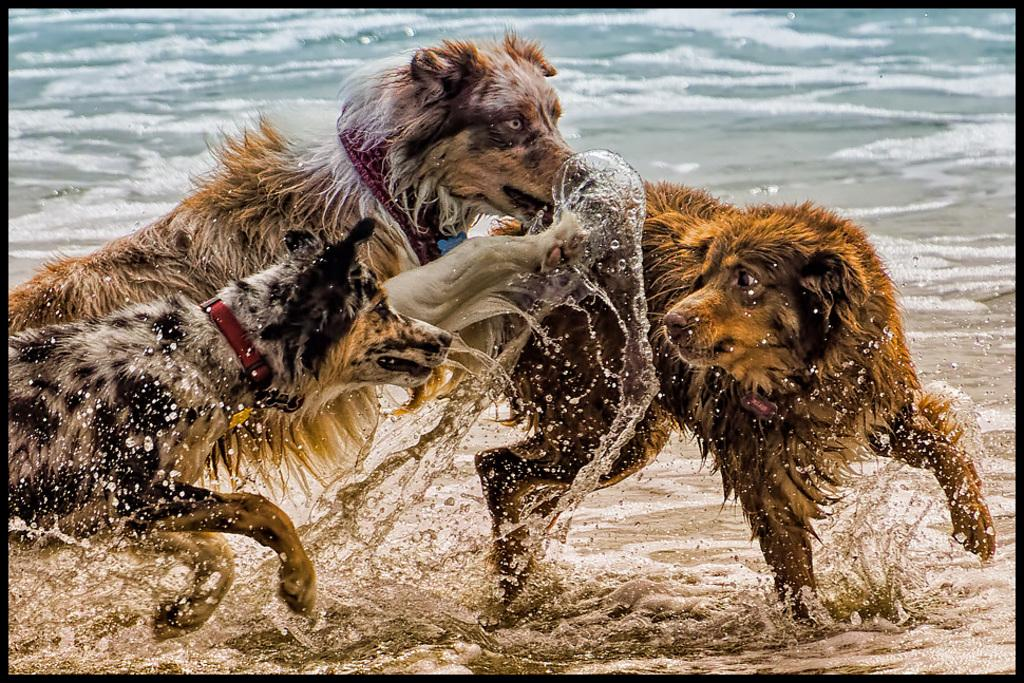How many dogs are present in the image? There are three dogs in the image. What are the dogs doing in the image? The dogs are fighting in the image. Where are the dogs located in the image? The dogs are in the center of the image. What can be seen at the bottom of the image? There is a river at the bottom of the image. What type of tent can be seen in the image? There is no tent present in the image. What color is the cable that the dogs are fighting over in the image? There is no cable present in the image; the dogs are fighting with each other. 